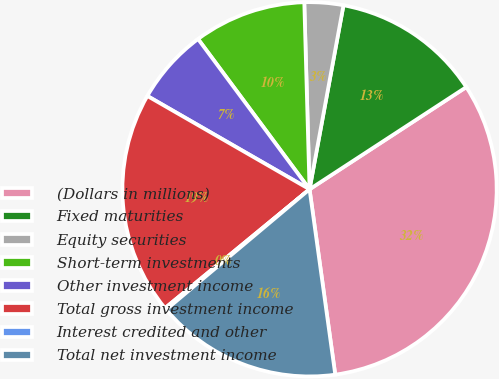<chart> <loc_0><loc_0><loc_500><loc_500><pie_chart><fcel>(Dollars in millions)<fcel>Fixed maturities<fcel>Equity securities<fcel>Short-term investments<fcel>Other investment income<fcel>Total gross investment income<fcel>Interest credited and other<fcel>Total net investment income<nl><fcel>32.0%<fcel>12.9%<fcel>3.35%<fcel>9.71%<fcel>6.53%<fcel>19.26%<fcel>0.16%<fcel>16.08%<nl></chart> 